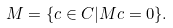<formula> <loc_0><loc_0><loc_500><loc_500>M = \{ c \in C | M c = 0 \} .</formula> 